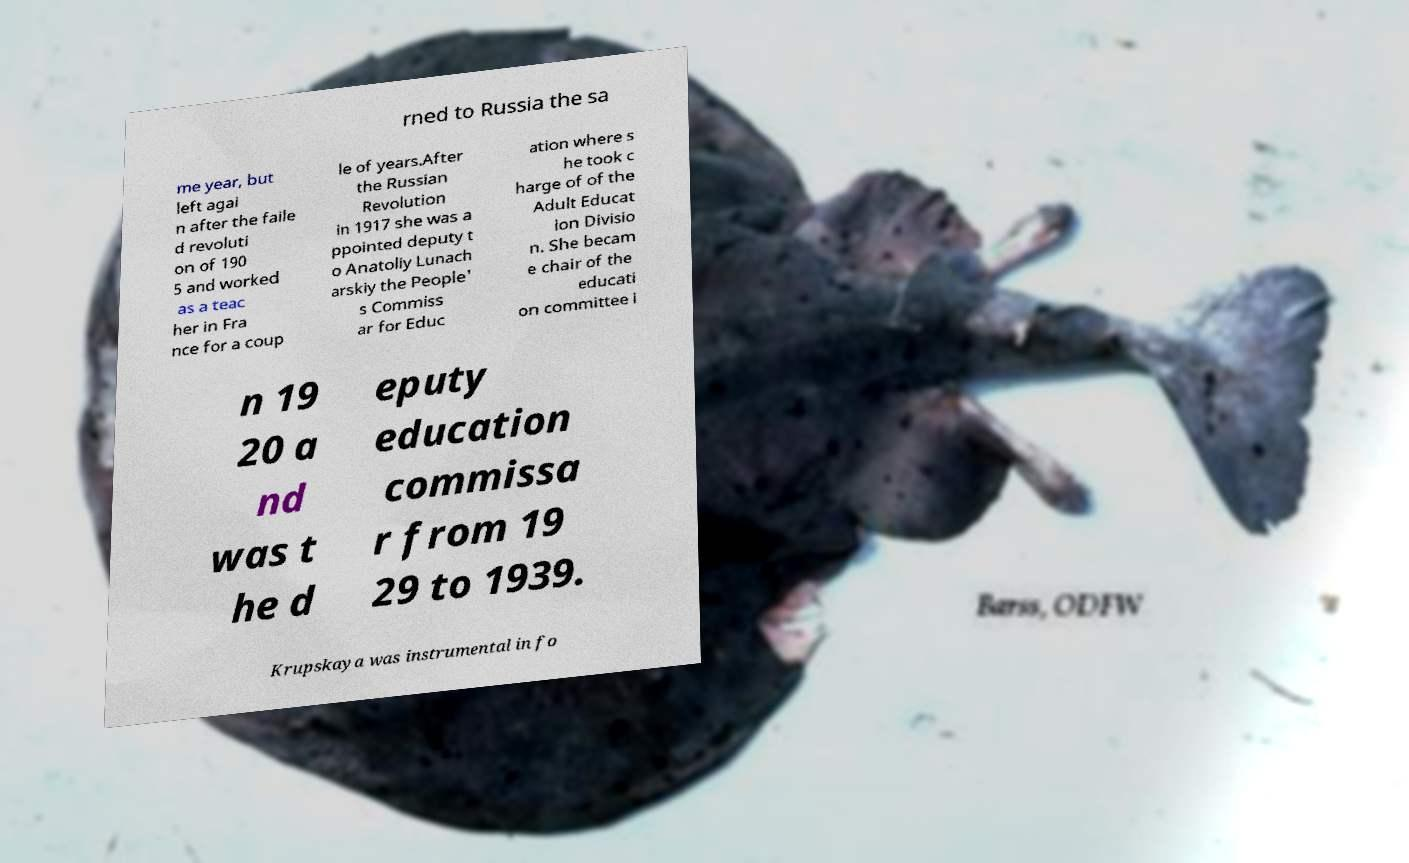Can you read and provide the text displayed in the image?This photo seems to have some interesting text. Can you extract and type it out for me? rned to Russia the sa me year, but left agai n after the faile d revoluti on of 190 5 and worked as a teac her in Fra nce for a coup le of years.After the Russian Revolution in 1917 she was a ppointed deputy t o Anatoliy Lunach arskiy the People' s Commiss ar for Educ ation where s he took c harge of of the Adult Educat ion Divisio n. She becam e chair of the educati on committee i n 19 20 a nd was t he d eputy education commissa r from 19 29 to 1939. Krupskaya was instrumental in fo 